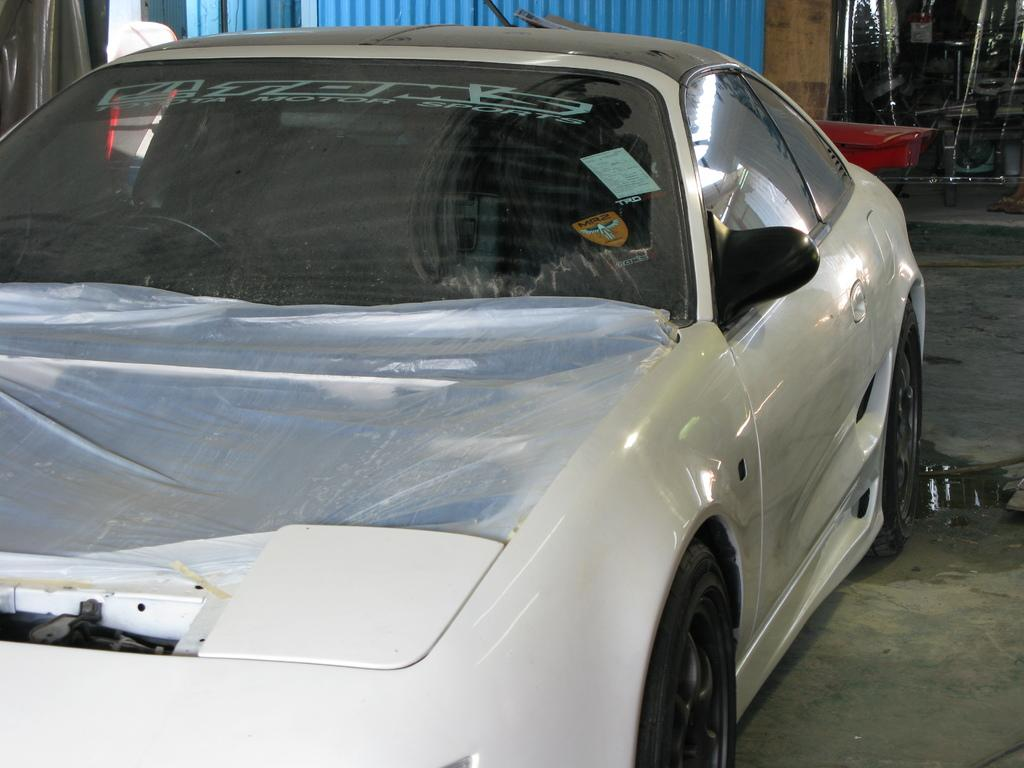What is the main subject of the image? The main subject of the image is a car. Where is the car located in the image? The car is parked on a path. What is visible behind the car? There is an iron sheet behind the vehicle, and there are other unspecified things visible behind the vehicle. What type of owl can be seen sitting on the car in the image? There is no owl present in the image; it only features a car parked on a path with an iron sheet and other unspecified things visible behind it. 